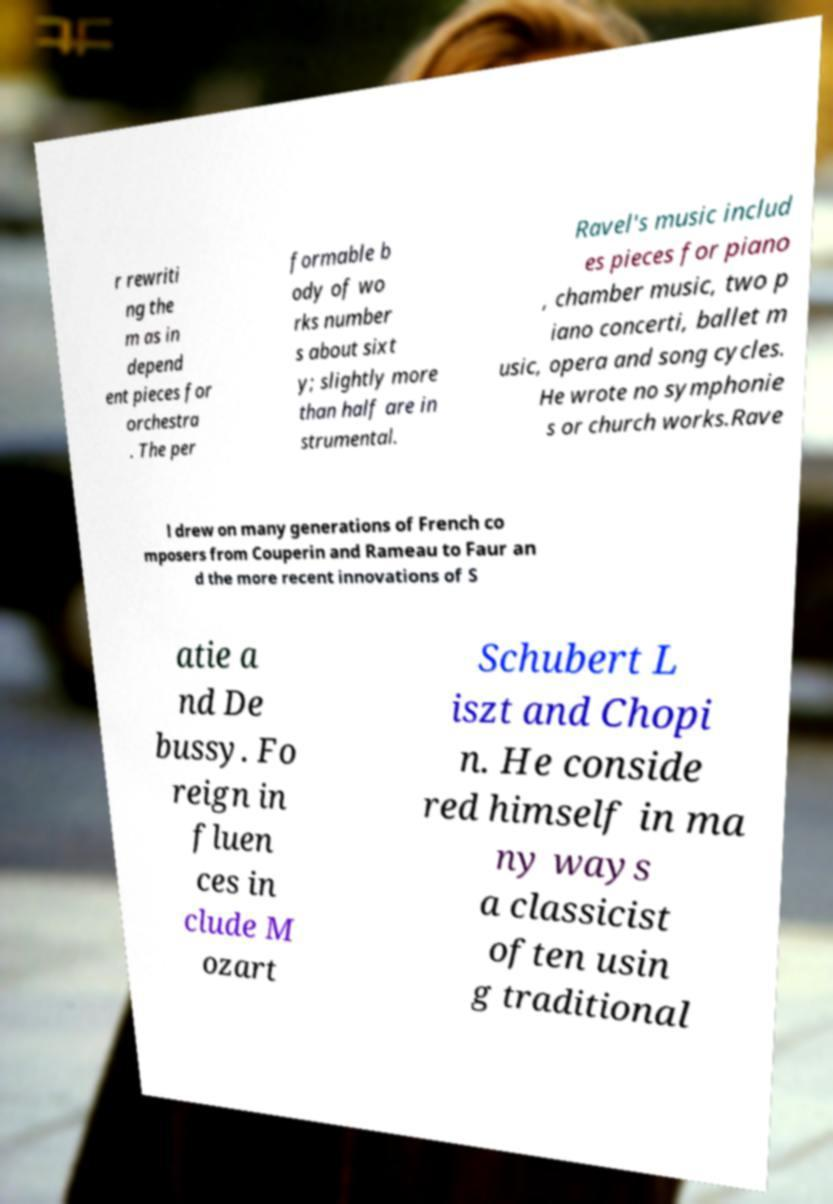Please read and relay the text visible in this image. What does it say? r rewriti ng the m as in depend ent pieces for orchestra . The per formable b ody of wo rks number s about sixt y; slightly more than half are in strumental. Ravel's music includ es pieces for piano , chamber music, two p iano concerti, ballet m usic, opera and song cycles. He wrote no symphonie s or church works.Rave l drew on many generations of French co mposers from Couperin and Rameau to Faur an d the more recent innovations of S atie a nd De bussy. Fo reign in fluen ces in clude M ozart Schubert L iszt and Chopi n. He conside red himself in ma ny ways a classicist often usin g traditional 